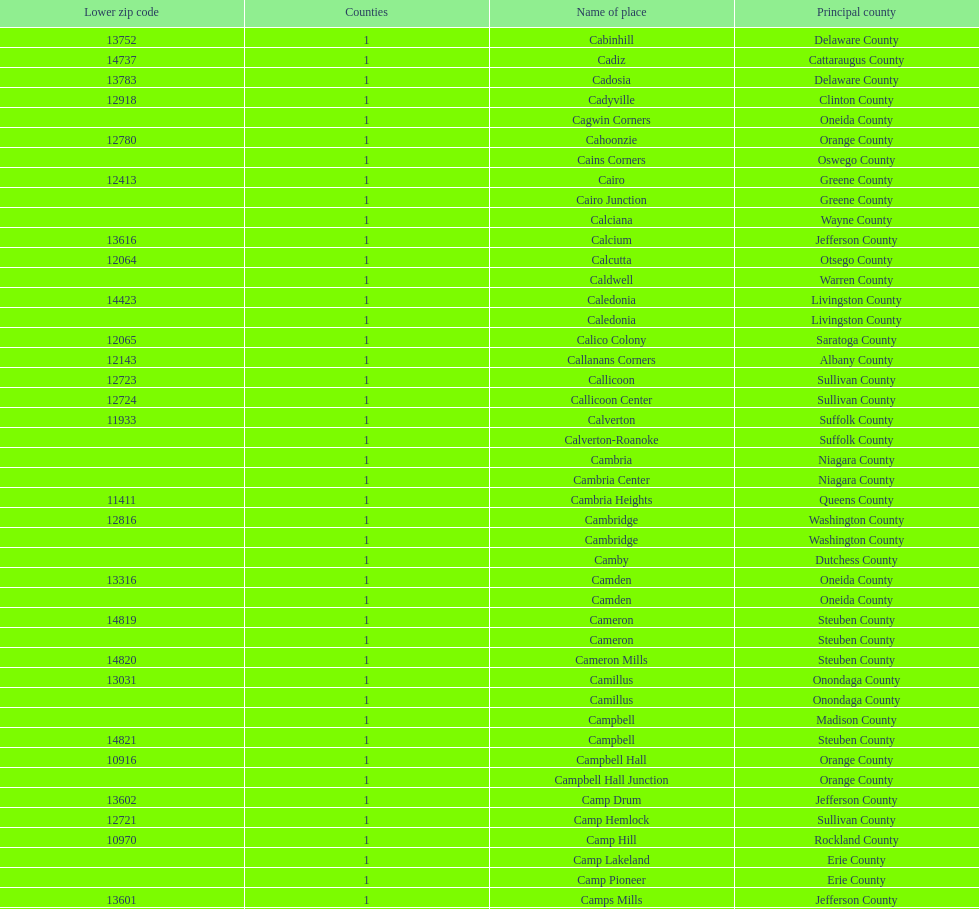How many total places are in greene county? 10. 